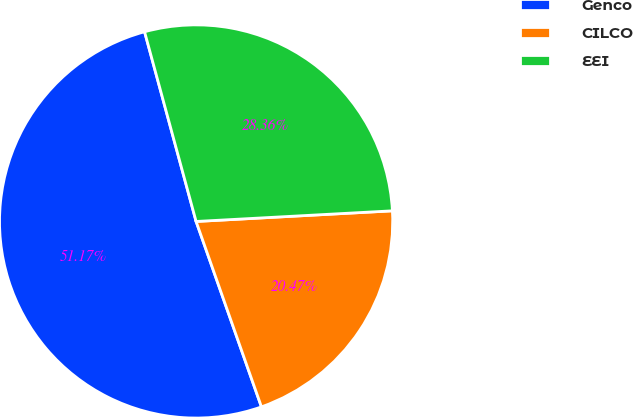<chart> <loc_0><loc_0><loc_500><loc_500><pie_chart><fcel>Genco<fcel>CILCO<fcel>EEI<nl><fcel>51.17%<fcel>20.47%<fcel>28.36%<nl></chart> 